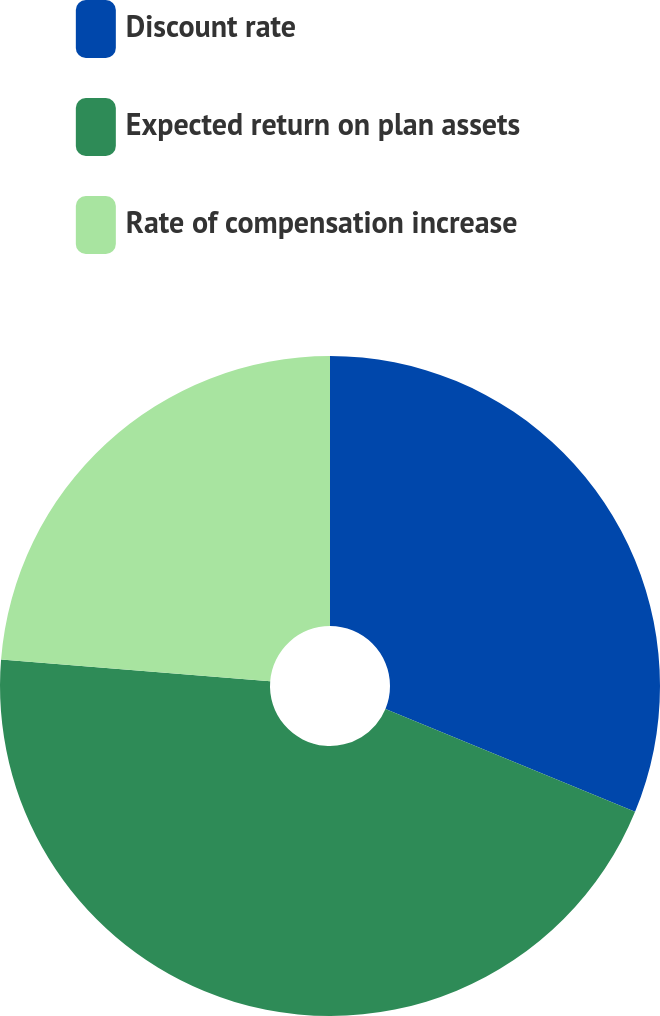Convert chart. <chart><loc_0><loc_0><loc_500><loc_500><pie_chart><fcel>Discount rate<fcel>Expected return on plan assets<fcel>Rate of compensation increase<nl><fcel>31.23%<fcel>45.06%<fcel>23.72%<nl></chart> 